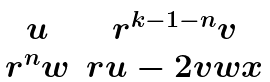Convert formula to latex. <formula><loc_0><loc_0><loc_500><loc_500>\begin{matrix} u & r ^ { k - 1 - n } v \\ r ^ { n } w & r u - 2 v w x \end{matrix}</formula> 